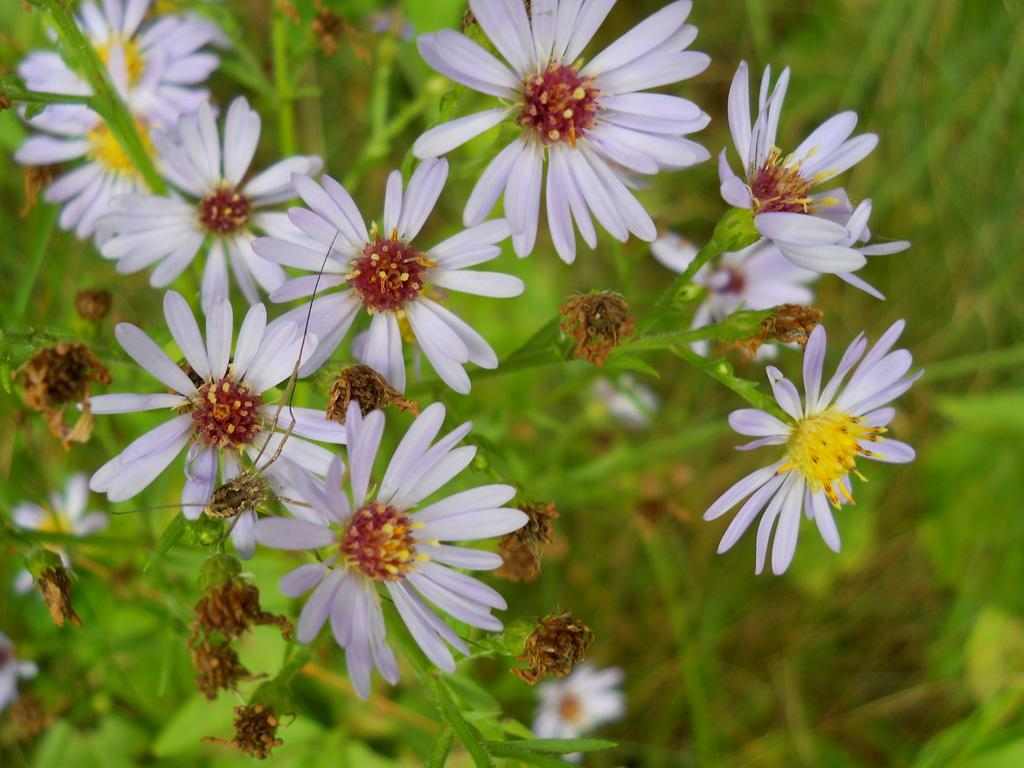What type of plants can be seen in the image? There are flowering plants in the image. Can you describe the setting where the plants are located? The image may have been taken in a garden. What flavor of ice cream does the father enjoy in the image? There is no father or ice cream present in the image; it features flowering plants in a possible garden setting. 